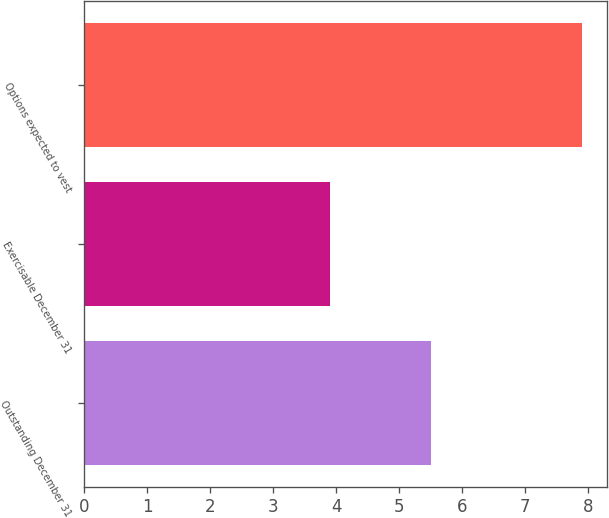Convert chart. <chart><loc_0><loc_0><loc_500><loc_500><bar_chart><fcel>Outstanding December 31<fcel>Exercisable December 31<fcel>Options expected to vest<nl><fcel>5.5<fcel>3.9<fcel>7.9<nl></chart> 